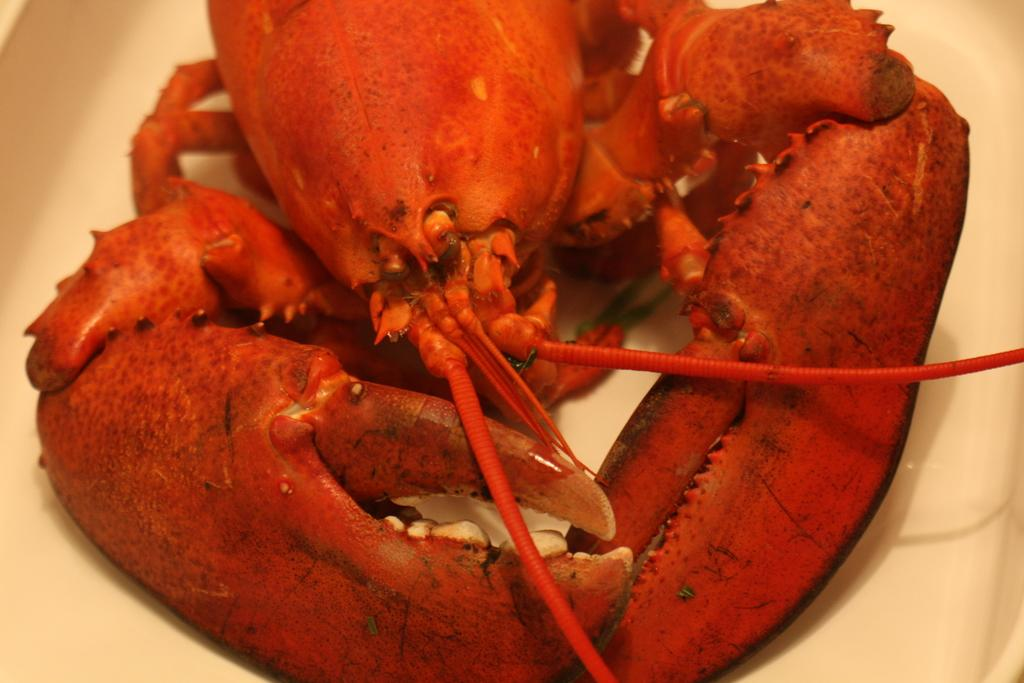What type of food can be seen in the image? The food in the image is in orange color. What color is the plate that holds the food? The plate is in white color. How does the baby follow the rule in the image? There is no baby or rule present in the image. 